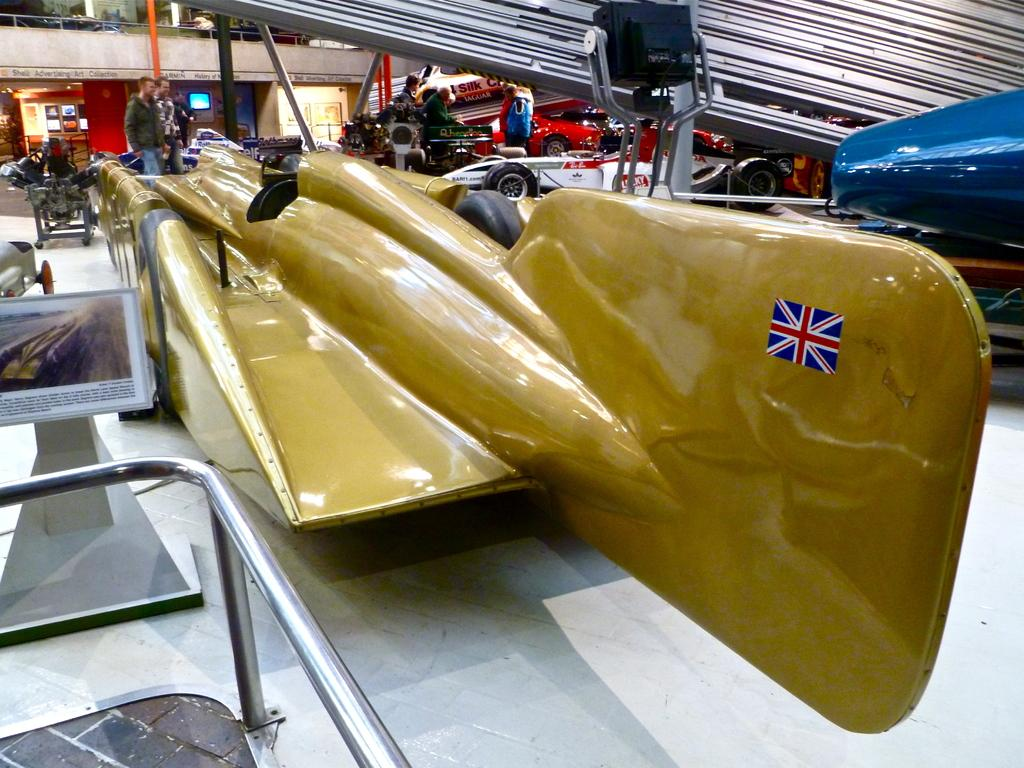What types of subjects can be seen in the image? There are people and vehicles in the image. What objects are present in the image? There are rods, a board on a stand, and a metal object in the image. What is the setting of the image? There is a floor, a railing, a wall, and a screen in the background of the image. What else can be seen in the background of the image? There are objects in the background of the image. What time does the clock on the wall show in the image? There is no clock present in the image. What suggestion is being made by the people in the image? The image does not depict a situation where a suggestion is being made; it simply shows people and vehicles in a particular setting. 